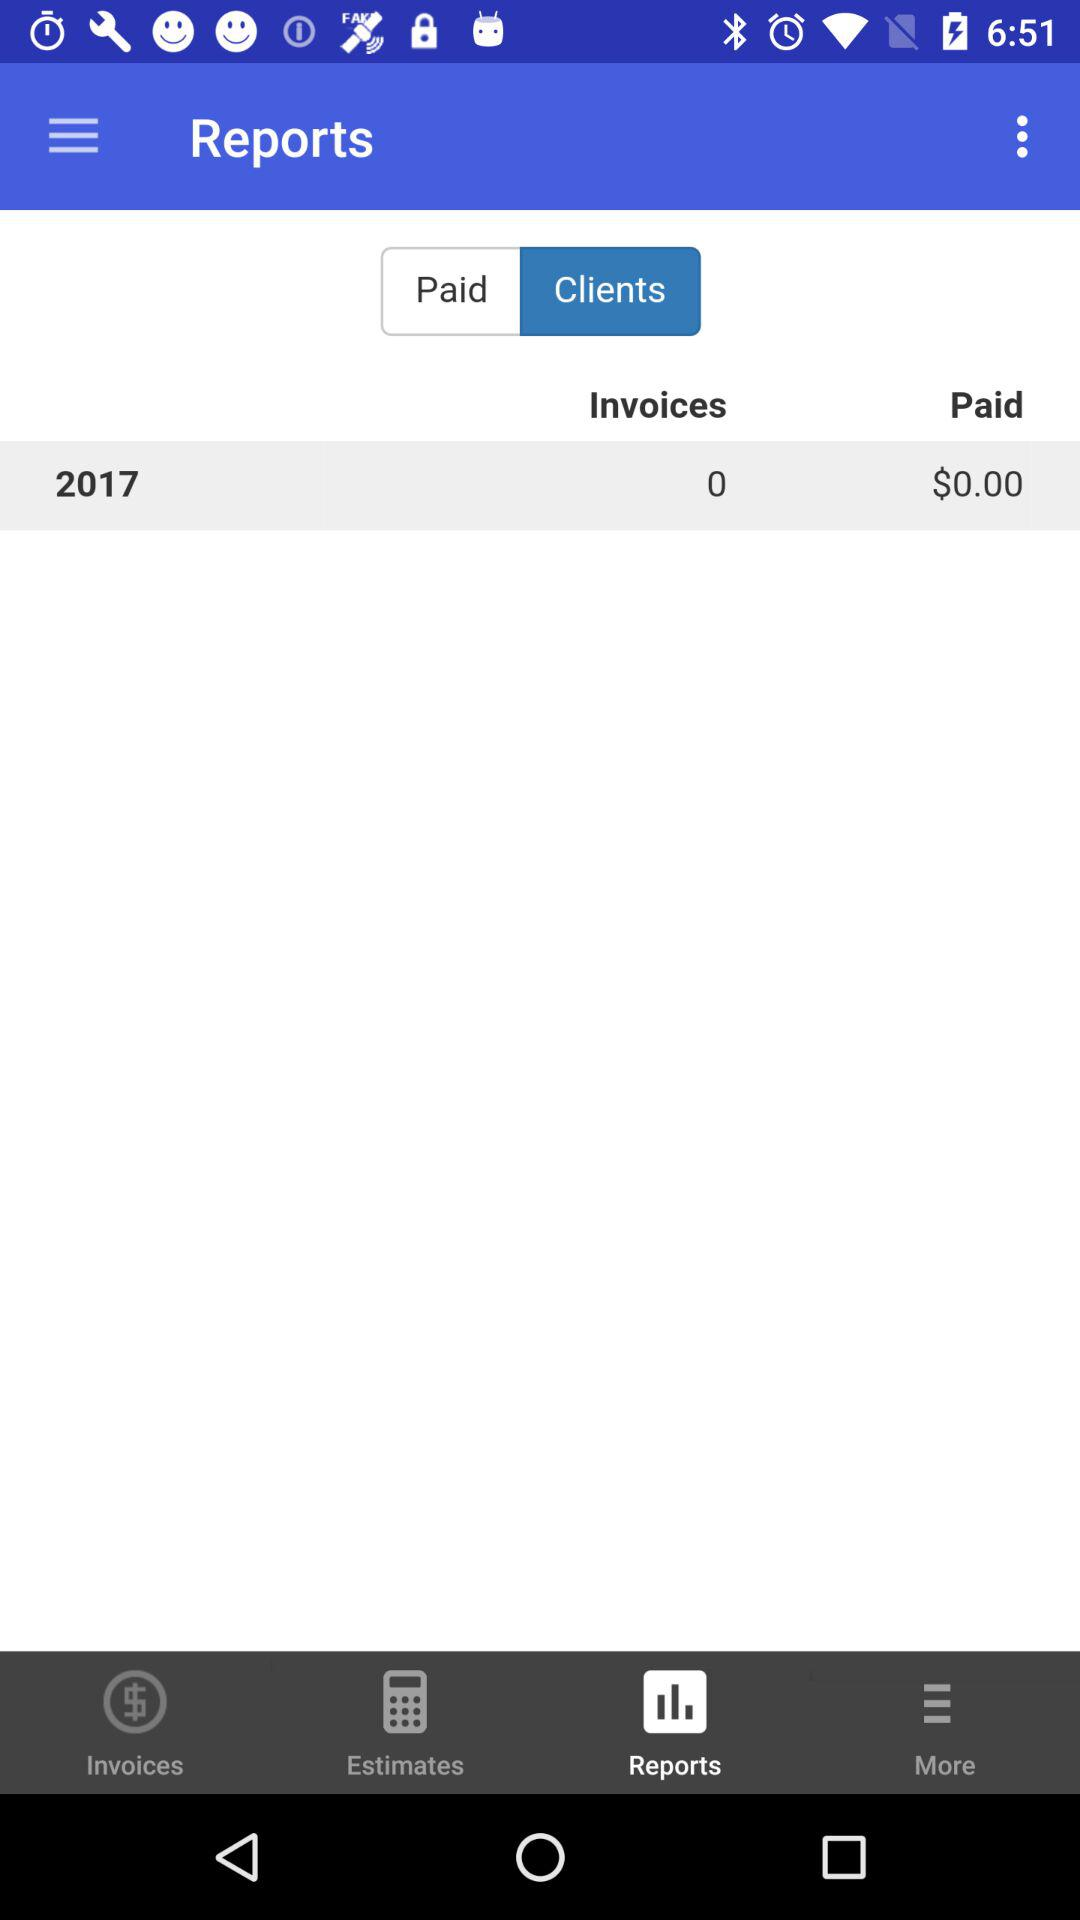Which tab is selected? The selected tabs are "Clients" and "Reports". 